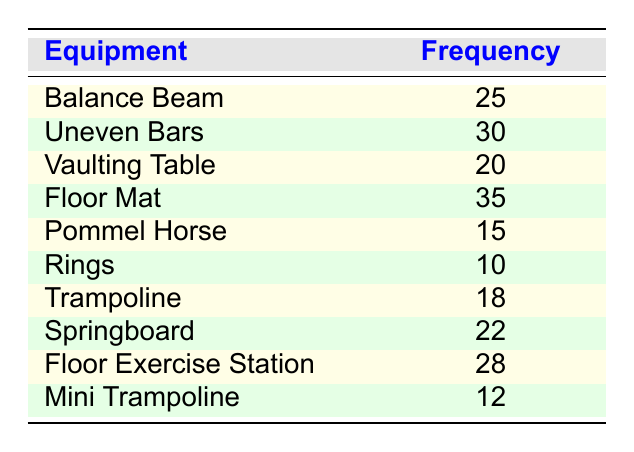What is the frequency of usage for the Floor Mat? According to the table, the Floor Mat has a recorded frequency of 35.
Answer: 35 Which equipment has the highest frequency of usage? The highest frequency in the table is for the Floor Mat, which has a frequency of 35.
Answer: Floor Mat How many more times is the usage of Uneven Bars compared to Rings? From the table, the frequency of Uneven Bars is 30, while the frequency of Rings is 10. The difference is 30 - 10 = 20.
Answer: 20 What is the average frequency of usage for all equipment listed? To calculate the average, we sum all the frequencies (25 + 30 + 20 + 35 + 15 + 10 + 18 + 22 + 28 + 12 =  1 5 0) and divide by the number of equipment (10). So, 150 / 10 = 15.
Answer: 15 Is the frequency of usage for the Pommel Horse greater than the Mini Trampoline? The Pommel Horse has a frequency of 15, and the Mini Trampoline has a frequency of 12. Since 15 is greater than 12, the answer is yes.
Answer: Yes Which equipment has the least frequency of usage? The Rings have the smallest frequency of usage according to the table, with a frequency of 10.
Answer: Rings What is the sum of the frequencies for the Springboard and the Trampoline? From the table, the frequency of Springboard is 22 and the frequency of Trampoline is 18. Adding these gives us 22 + 18 = 40.
Answer: 40 How does the frequency of the Vaulting Table compare to that of the Floor Exercise Station? Vaulting Table has a frequency of 20, while Floor Exercise Station has a frequency of 28. Since 20 is less than 28, the Vaulting Table has a lower frequency.
Answer: Lower Which two equipment have a combined frequency of usage greater than 40? The Floor Mat (35) and the Uneven Bars (30) have frequencies that add up to 65, which is greater than 40. Other combinations like Springboard (22) and Floor Exercise Station (28) also exceed 40 when added together.
Answer: Floor Mat and Uneven Bars, Springboard and Floor Exercise Station 